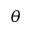Convert formula to latex. <formula><loc_0><loc_0><loc_500><loc_500>\theta</formula> 